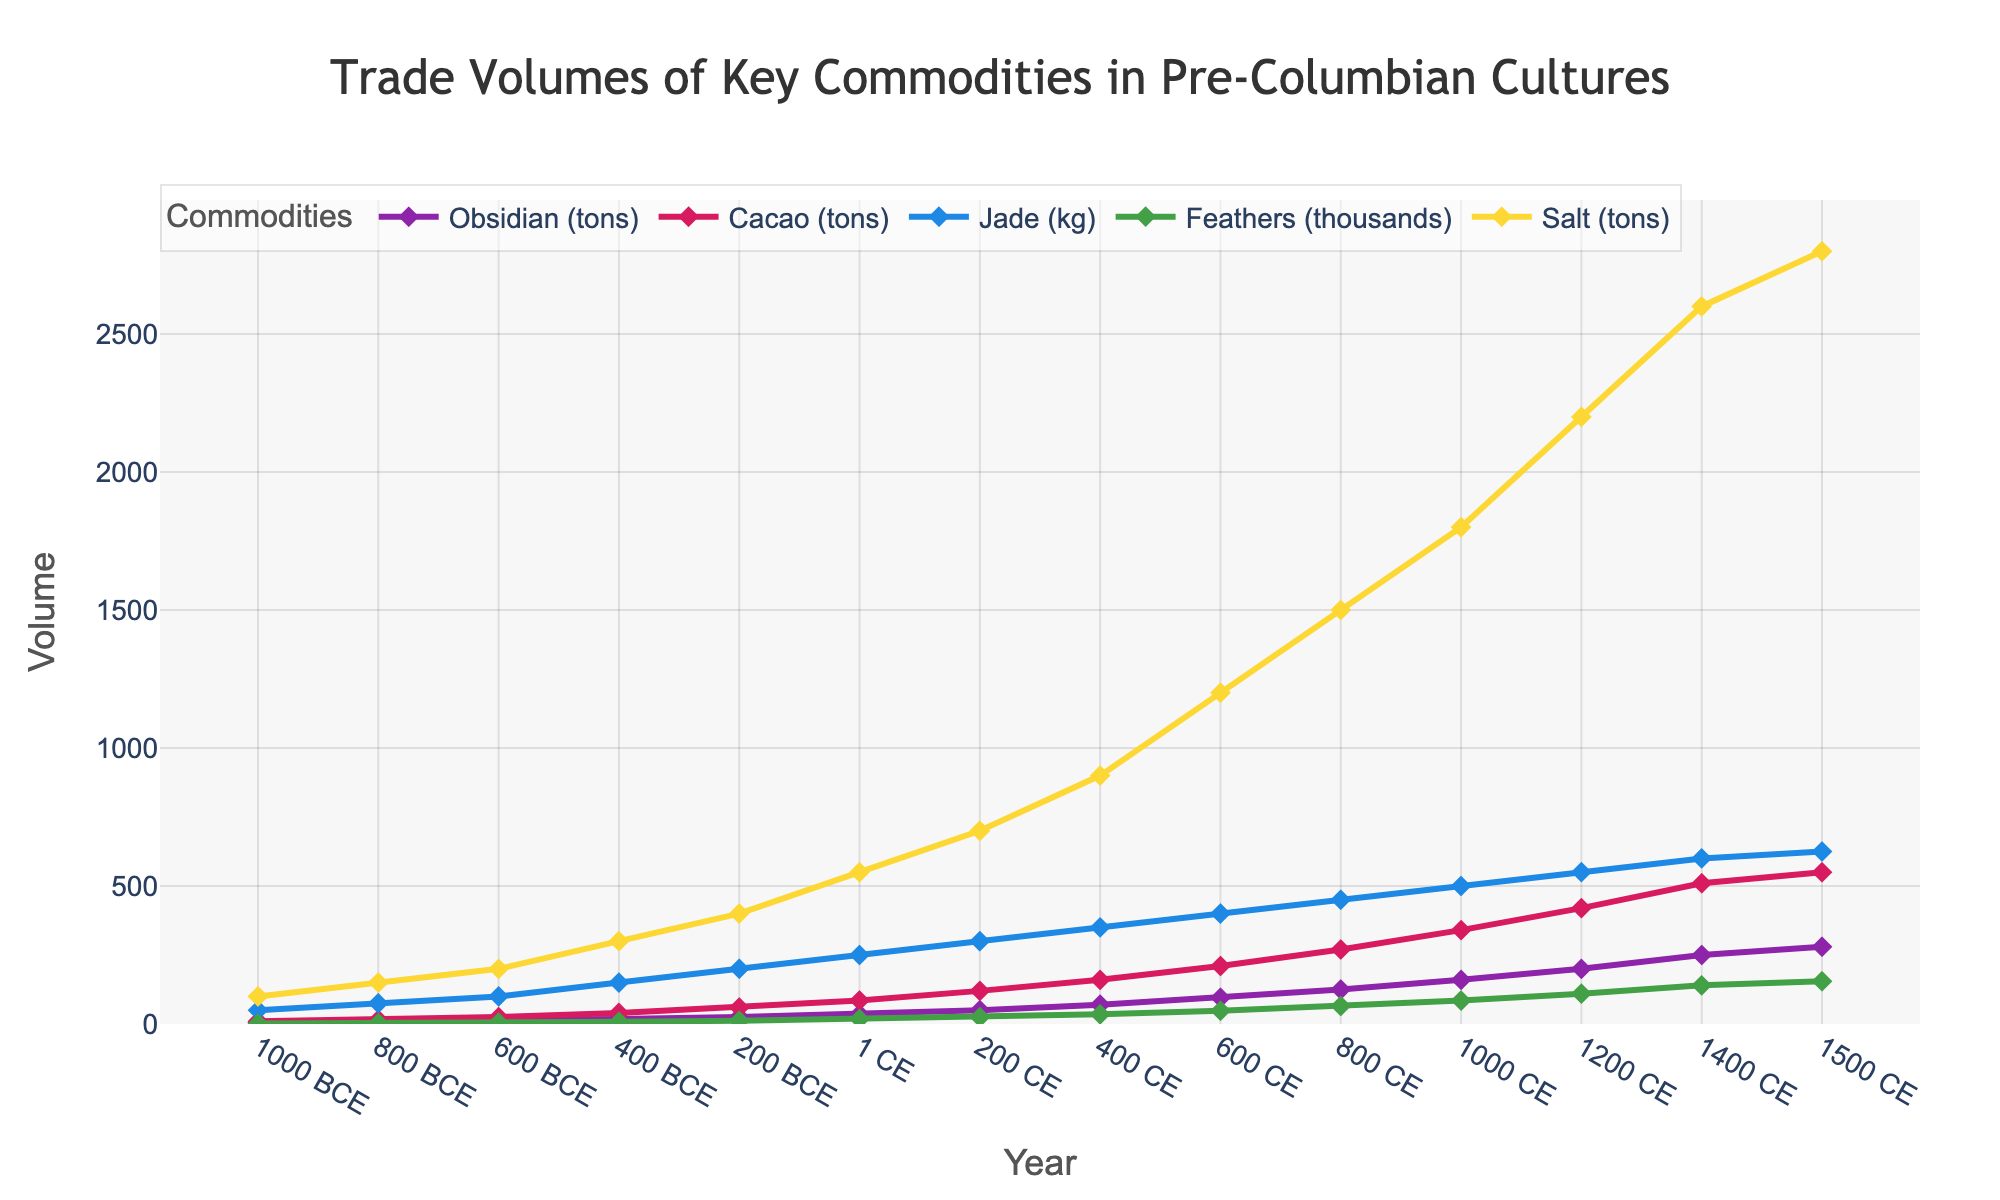What is the overall trend in the trade volume of obsidian between 1000 BCE and 1500 CE? The trade volume of obsidian consistently increases over time. Starting from 5 tons in 1000 BCE, it rises to 280 tons by 1500 CE. This shows a continual growth in the importance and trade of obsidian over the centuries.
Answer: Consistent increase Which commodity had the highest trade volume in 1200 CE, and what was the volume? Looking at the 1200 CE data point, Salt shows the highest trade volume among the commodities, with a volume of 2200 tons.
Answer: Salt, 2200 tons By looking at the line colors, which commodity showed the fastest growth rate between 400 CE and 600 CE? The green line, representing Feathers (thousands), shows the steepest incline between these years, indicating the fastest growth rate. The volume increases significantly from 35 thousand to 48 thousand feathers.
Answer: Feathers Between 800 BCE and 1 CE, which commodity increased the most in trade volume and by how much? For Obsidian: 35 - 8 = 27 tons; for Cacao: 85 - 15 = 70 tons; for Jade: 250 - 75 = 175 kg; for Feathers: 18 - 3 = 15 thousand feathers; for Salt: 550 - 150 = 400 tons. Salt's trade volume increased the most by 400 tons.
Answer: Salt, 400 tons How does the trade volume of Jade in 1500 CE compare to its volume in 1000 BCE? The trade volume of Jade was 50 kg in 1000 BCE and increased to 625 kg in 1500 CE. To compare, 625 kg - 50 kg = 575 kg increase.
Answer: Jade increased by 575 kg What can we say about the average trade volume of Cacao from 600 CE to 1200 CE? The Cacao volumes at these intervals are: 25, 60, 85, 120, 160, 210, 270, and 340 tons. Summing these: (25 + 60 + 85 + 120 + 160 + 210 + 270 + 340 = 1270), then dividing by 8 (years) gives the average: 1270 / 8 = 158.75 tons.
Answer: 158.75 tons Which commodity saw the greatest increase in trade volume from 200 BCE to 1 CE? For Obsidian: 35 - 25 = 10 tons; for Cacao: 85 - 60 = 25 tons; for Jade: 250 - 200 = 50 kg; for Feathers: 18 - 12 = 6 thousand feathers; for Salt: 550 - 400 = 150 tons. Jade's trade volume increased the most by 50 kg.
Answer: Jade, 50 kg During which century did the Feathers trade volume reach 110,000? Glancing at the chart, it's 1200 CE when Feathers reached 110,000 trade volume, which is correct as per the data provided. The blue line representing Feathers intersects the Y-axis at 110,000.
Answer: 1200 CE What was the trade volume difference of Salt between 1000 CE and 1500 CE? By observing the Salt volumes: 1800 tons in 1000 CE and 2800 tons in 1500 CE. The difference is: 2800 - 1800 = 1000 tons.
Answer: 1000 tons 